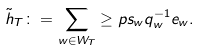Convert formula to latex. <formula><loc_0><loc_0><loc_500><loc_500>\tilde { h } _ { T } \colon = \sum _ { w \in W _ { T } } \geq p s _ { w } q ^ { - 1 } _ { w } e _ { w } .</formula> 